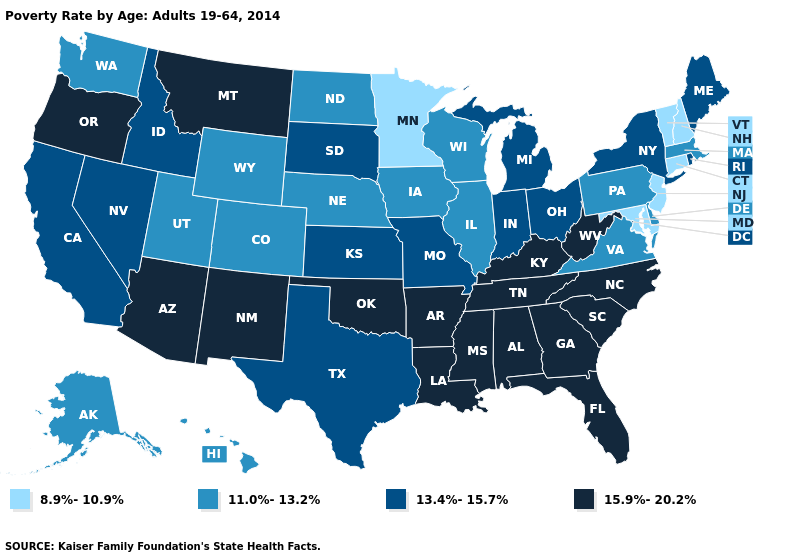Does the map have missing data?
Quick response, please. No. Which states hav the highest value in the West?
Quick response, please. Arizona, Montana, New Mexico, Oregon. Which states have the highest value in the USA?
Concise answer only. Alabama, Arizona, Arkansas, Florida, Georgia, Kentucky, Louisiana, Mississippi, Montana, New Mexico, North Carolina, Oklahoma, Oregon, South Carolina, Tennessee, West Virginia. Does the first symbol in the legend represent the smallest category?
Be succinct. Yes. What is the lowest value in the USA?
Quick response, please. 8.9%-10.9%. How many symbols are there in the legend?
Keep it brief. 4. Does Colorado have a lower value than Iowa?
Write a very short answer. No. Among the states that border Texas , which have the highest value?
Concise answer only. Arkansas, Louisiana, New Mexico, Oklahoma. Is the legend a continuous bar?
Concise answer only. No. What is the highest value in the South ?
Short answer required. 15.9%-20.2%. Name the states that have a value in the range 13.4%-15.7%?
Quick response, please. California, Idaho, Indiana, Kansas, Maine, Michigan, Missouri, Nevada, New York, Ohio, Rhode Island, South Dakota, Texas. Name the states that have a value in the range 15.9%-20.2%?
Give a very brief answer. Alabama, Arizona, Arkansas, Florida, Georgia, Kentucky, Louisiana, Mississippi, Montana, New Mexico, North Carolina, Oklahoma, Oregon, South Carolina, Tennessee, West Virginia. Among the states that border North Carolina , does Virginia have the lowest value?
Write a very short answer. Yes. Which states have the lowest value in the USA?
Keep it brief. Connecticut, Maryland, Minnesota, New Hampshire, New Jersey, Vermont. 